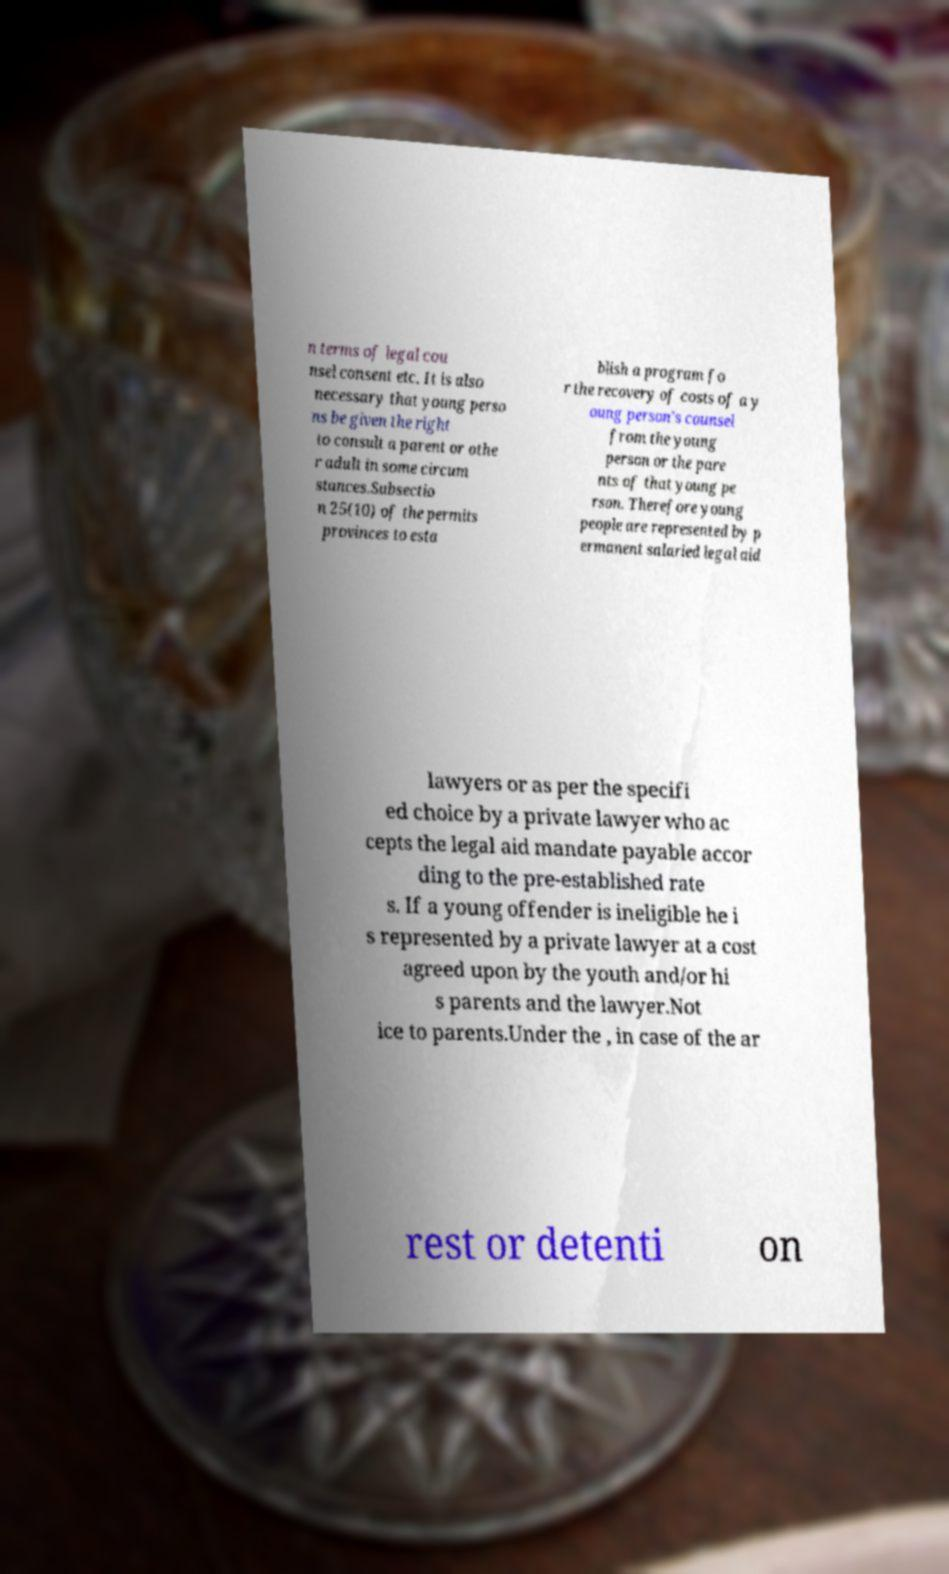Can you read and provide the text displayed in the image?This photo seems to have some interesting text. Can you extract and type it out for me? n terms of legal cou nsel consent etc. It is also necessary that young perso ns be given the right to consult a parent or othe r adult in some circum stances.Subsectio n 25(10) of the permits provinces to esta blish a program fo r the recovery of costs of a y oung person's counsel from the young person or the pare nts of that young pe rson. Therefore young people are represented by p ermanent salaried legal aid lawyers or as per the specifi ed choice by a private lawyer who ac cepts the legal aid mandate payable accor ding to the pre-established rate s. If a young offender is ineligible he i s represented by a private lawyer at a cost agreed upon by the youth and/or hi s parents and the lawyer.Not ice to parents.Under the , in case of the ar rest or detenti on 